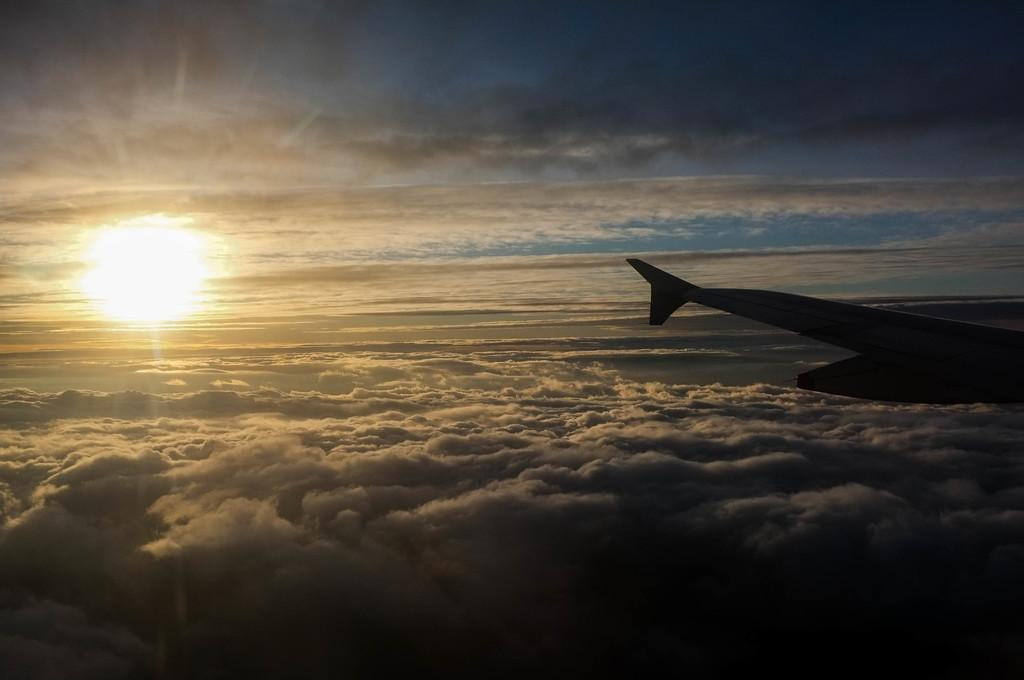What is the main subject of the image? The main subject of the image is an airplane. Where is the airplane located in the image? The airplane is in the air. What can be seen in the background of the image? There are clouds, the sun, and the sky visible in the background of the image. How many legs does the airplane have in the image? Airplanes do not have legs; they have wings and a fuselage. The question is based on the absurd topic "legs" and is not relevant to the image. 